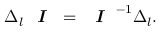Convert formula to latex. <formula><loc_0><loc_0><loc_500><loc_500>\Delta _ { l } I = I ^ { - 1 } \Delta _ { l } .</formula> 